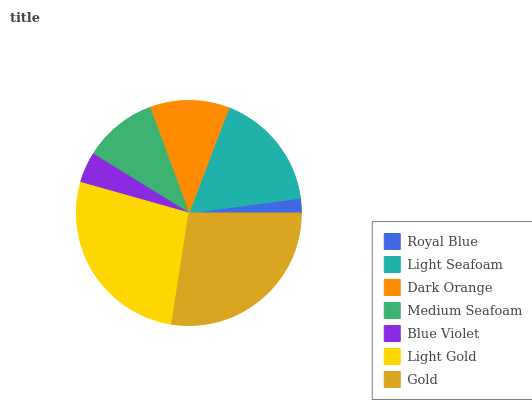Is Royal Blue the minimum?
Answer yes or no. Yes. Is Gold the maximum?
Answer yes or no. Yes. Is Light Seafoam the minimum?
Answer yes or no. No. Is Light Seafoam the maximum?
Answer yes or no. No. Is Light Seafoam greater than Royal Blue?
Answer yes or no. Yes. Is Royal Blue less than Light Seafoam?
Answer yes or no. Yes. Is Royal Blue greater than Light Seafoam?
Answer yes or no. No. Is Light Seafoam less than Royal Blue?
Answer yes or no. No. Is Dark Orange the high median?
Answer yes or no. Yes. Is Dark Orange the low median?
Answer yes or no. Yes. Is Medium Seafoam the high median?
Answer yes or no. No. Is Blue Violet the low median?
Answer yes or no. No. 